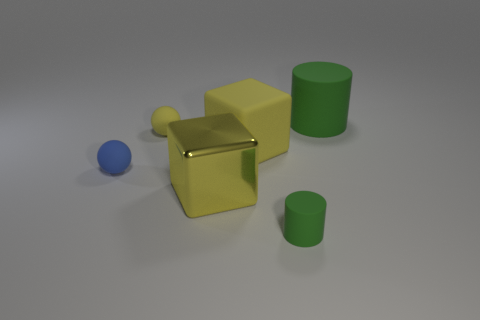How many objects are in this image and what are their colors? The image displays a total of five objects. There is one blue sphere, one yellow cube, one green cylinder, one small green cylinder, and a yellow object shaped like an 'L' or angular figure. Can you describe the lighting and shadows present in the scene? The lighting in the scene appears to be diffused, casting soft shadows to the right of each object, suggesting that the light source is located to the top left of the scene. 